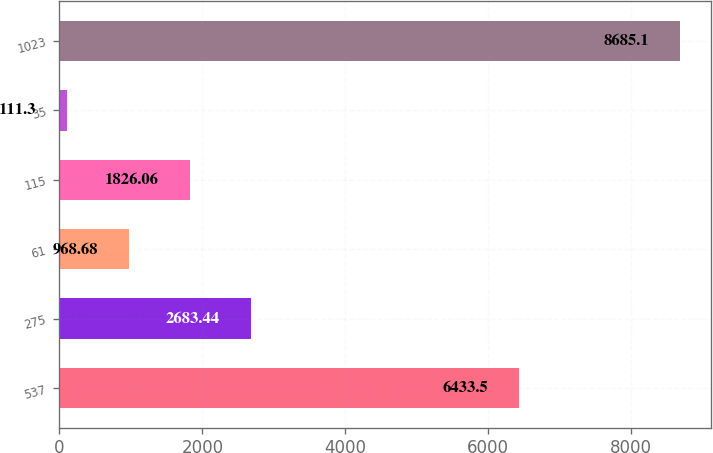Convert chart to OTSL. <chart><loc_0><loc_0><loc_500><loc_500><bar_chart><fcel>537<fcel>275<fcel>61<fcel>115<fcel>35<fcel>1023<nl><fcel>6433.5<fcel>2683.44<fcel>968.68<fcel>1826.06<fcel>111.3<fcel>8685.1<nl></chart> 